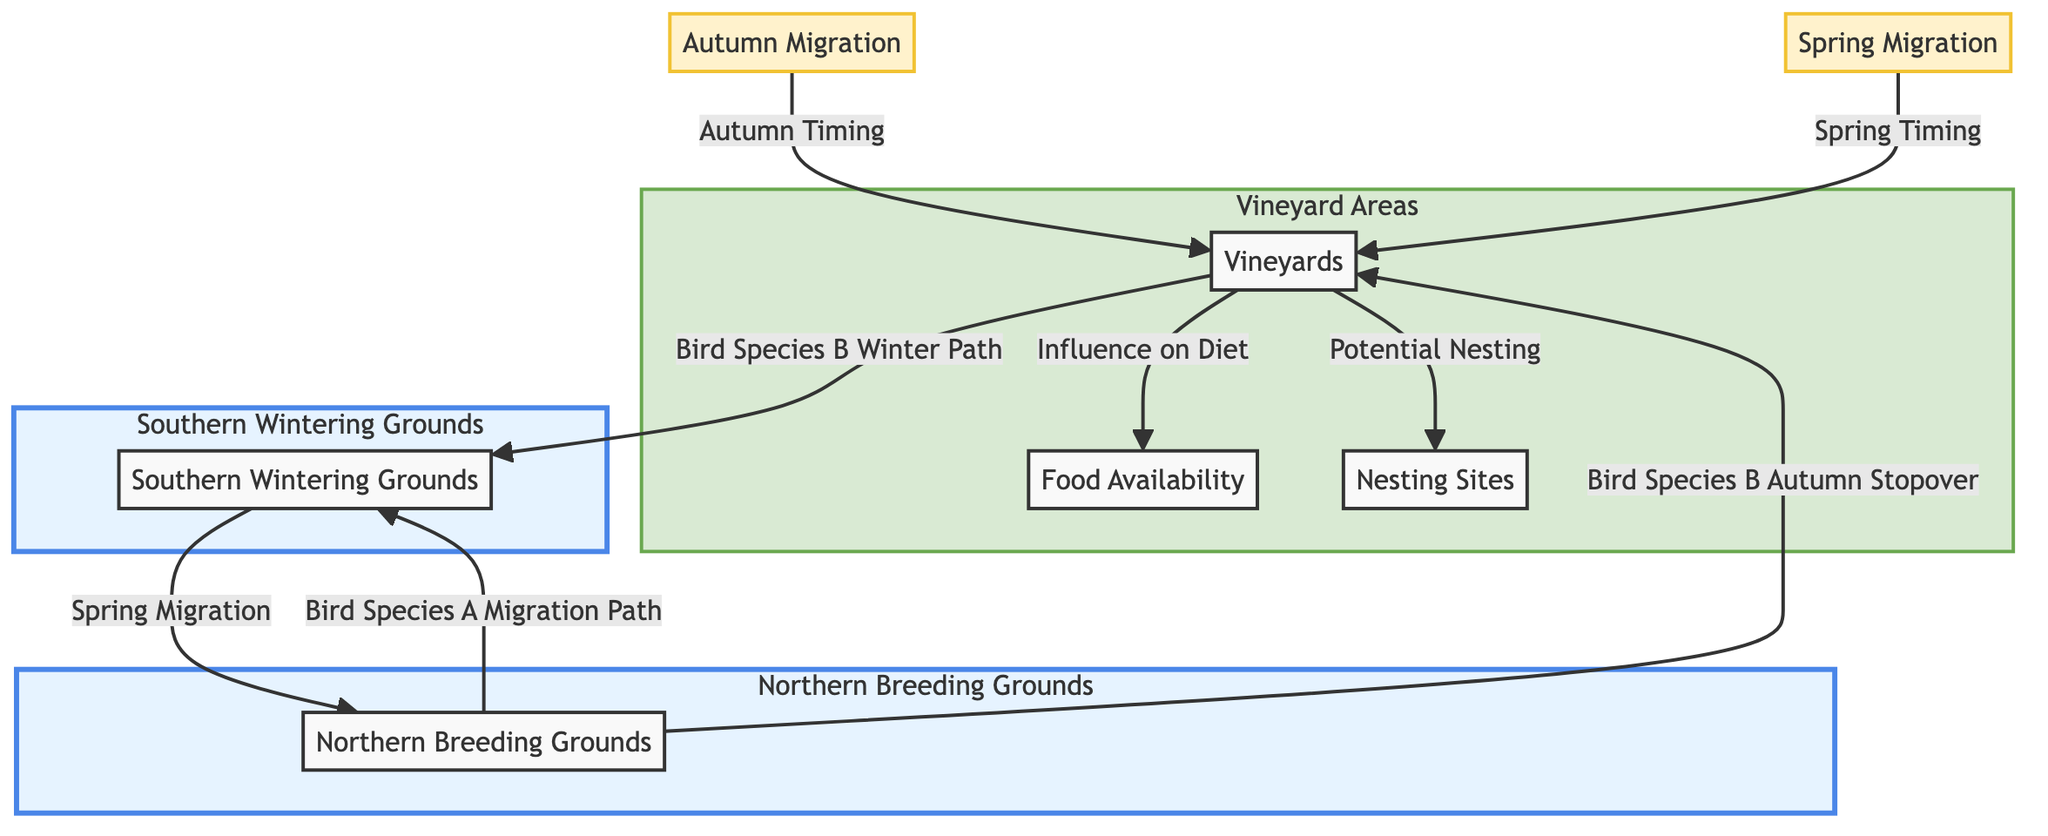What are the two main types of migration depicted in the diagram? The diagram shows two types of migration: Autumn Migration and Spring Migration, represented by the nodes AM and SM.
Answer: Autumn Migration, Spring Migration Which bird species has an autumn stopover in vineyard areas? The diagram specifies that Bird Species B has an autumn stopover represented by the edge from Northern Breeding Grounds to Vineyards.
Answer: Bird Species B How many migration paths are illustrated in the diagram? There are three paths illustrated: one from Northern Breeding Grounds to Southern Wintering Grounds for Bird Species A, one for Bird Species B from Northern Breeding Grounds to Vineyards, and one from Vineyards to Southern Wintering Grounds.
Answer: Three What is influenced by vineyard areas according to the diagram? The diagram indicates that Food Availability and Potential Nesting are influenced by vineyard areas, as shown by the edges leading from Vineyards to FA and NS.
Answer: Food Availability, Potential Nesting In which direction do the bird species migrate from Southern Wintering Grounds? The diagram shows that bird species migrate from Southern Wintering Grounds back to the Northern Breeding Grounds during Spring Migration.
Answer: Northern Breeding Grounds How does the food availability relate to vineyards? The diagram connects Food Availability to vineyard areas, indicating the influence of vineyards on the diet of the birds depicted in the diagram.
Answer: Influence on Diet What is illustrated as a winter path for bird species B? The diagram indicates that the winter path for Bird Species B travels from Vineyard Areas to Southern Wintering Grounds.
Answer: Southern Wintering Grounds Which area is specifically designated for food sources in the diagram? The area designated for food sources in the diagram is labeled as Food Availability, noted within the Vineyard Areas.
Answer: Food Availability How do vineyard areas affect the timing of migrations? The diagram connects Autumn Migration and Spring Migration to vineyard areas, implying that these timings are influenced by the presence of vineyards.
Answer: Influenced by vineyards 